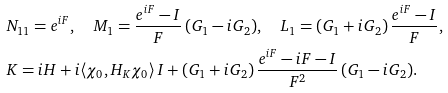<formula> <loc_0><loc_0><loc_500><loc_500>& N _ { 1 1 } = e ^ { i F } , \quad M _ { 1 } = \frac { e ^ { i F } - I } { F } \, ( G _ { 1 } - i G _ { 2 } ) , \quad L _ { 1 } = ( G _ { 1 } + i G _ { 2 } ) \, \frac { e ^ { i F } - I } { F } , \\ & K = i H + i \langle \chi _ { 0 } , H _ { K } \chi _ { 0 } \rangle \, I + ( G _ { 1 } + i G _ { 2 } ) \, \frac { e ^ { i F } - i F - I } { F ^ { 2 } } \, ( G _ { 1 } - i G _ { 2 } ) .</formula> 